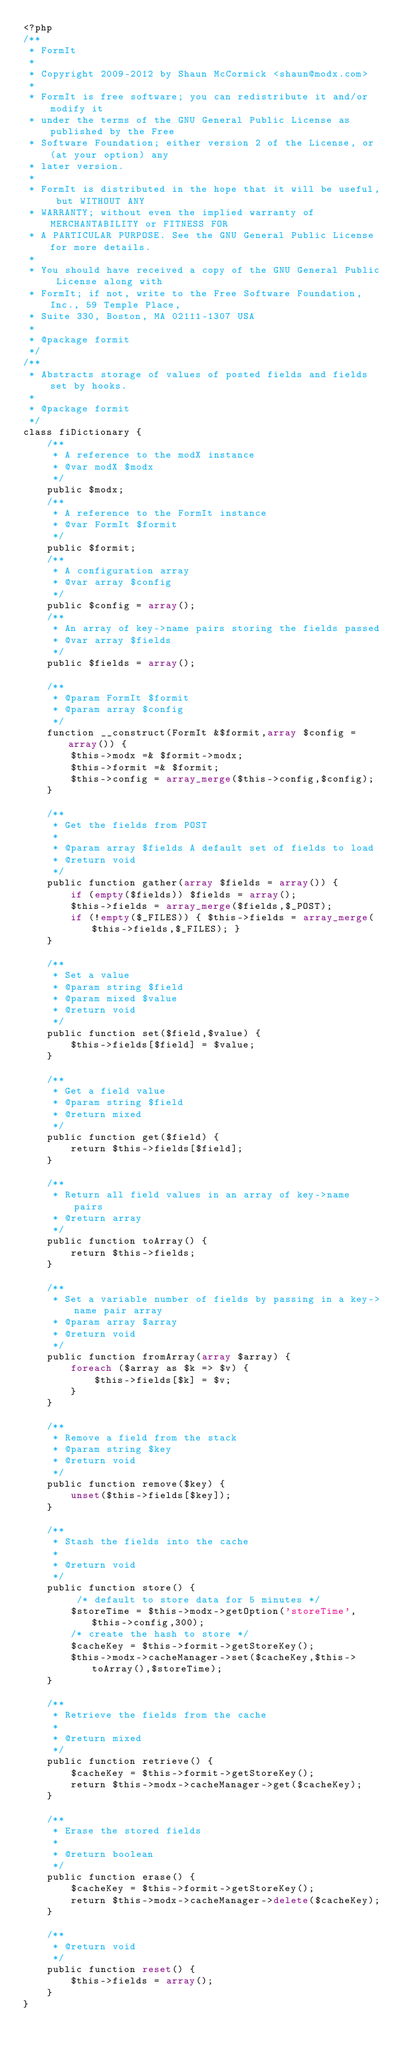Convert code to text. <code><loc_0><loc_0><loc_500><loc_500><_PHP_><?php
/**
 * FormIt
 *
 * Copyright 2009-2012 by Shaun McCormick <shaun@modx.com>
 *
 * FormIt is free software; you can redistribute it and/or modify it
 * under the terms of the GNU General Public License as published by the Free
 * Software Foundation; either version 2 of the License, or (at your option) any
 * later version.
 *
 * FormIt is distributed in the hope that it will be useful, but WITHOUT ANY
 * WARRANTY; without even the implied warranty of MERCHANTABILITY or FITNESS FOR
 * A PARTICULAR PURPOSE. See the GNU General Public License for more details.
 *
 * You should have received a copy of the GNU General Public License along with
 * FormIt; if not, write to the Free Software Foundation, Inc., 59 Temple Place,
 * Suite 330, Boston, MA 02111-1307 USA
 *
 * @package formit
 */
/**
 * Abstracts storage of values of posted fields and fields set by hooks.
 *
 * @package formit
 */
class fiDictionary {
    /**
     * A reference to the modX instance
     * @var modX $modx
     */
    public $modx;
    /**
     * A reference to the FormIt instance
     * @var FormIt $formit
     */
    public $formit;
    /**
     * A configuration array
     * @var array $config
     */
    public $config = array();
    /**
     * An array of key->name pairs storing the fields passed
     * @var array $fields
     */
    public $fields = array();

    /**
     * @param FormIt $formit
     * @param array $config
     */
    function __construct(FormIt &$formit,array $config = array()) {
        $this->modx =& $formit->modx;
        $this->formit =& $formit;
        $this->config = array_merge($this->config,$config);
    }

    /**
     * Get the fields from POST
     *
     * @param array $fields A default set of fields to load
     * @return void
     */
    public function gather(array $fields = array()) {
        if (empty($fields)) $fields = array();
        $this->fields = array_merge($fields,$_POST);
        if (!empty($_FILES)) { $this->fields = array_merge($this->fields,$_FILES); }
    }

    /**
     * Set a value
     * @param string $field
     * @param mixed $value
     * @return void
     */
    public function set($field,$value) {
        $this->fields[$field] = $value;
    }

    /**
     * Get a field value
     * @param string $field
     * @return mixed
     */
    public function get($field) {
        return $this->fields[$field];
    }

    /**
     * Return all field values in an array of key->name pairs
     * @return array
     */
    public function toArray() {
        return $this->fields;
    }

    /**
     * Set a variable number of fields by passing in a key->name pair array
     * @param array $array
     * @return void
     */
    public function fromArray(array $array) {
        foreach ($array as $k => $v) {
            $this->fields[$k] = $v;
        }
    }

    /**
     * Remove a field from the stack
     * @param string $key
     * @return void
     */
    public function remove($key) {
        unset($this->fields[$key]);
    }

    /**
     * Stash the fields into the cache
     * 
     * @return void
     */
    public function store() {
         /* default to store data for 5 minutes */
        $storeTime = $this->modx->getOption('storeTime',$this->config,300);
        /* create the hash to store */
        $cacheKey = $this->formit->getStoreKey();
        $this->modx->cacheManager->set($cacheKey,$this->toArray(),$storeTime);
    }

    /**
     * Retrieve the fields from the cache
     * 
     * @return mixed
     */
    public function retrieve() {
        $cacheKey = $this->formit->getStoreKey();
        return $this->modx->cacheManager->get($cacheKey);
    }

    /**
     * Erase the stored fields
     * 
     * @return boolean
     */
    public function erase() {
        $cacheKey = $this->formit->getStoreKey();
        return $this->modx->cacheManager->delete($cacheKey);
    }

    /**
     * @return void
     */
    public function reset() {
        $this->fields = array();
    }
}</code> 